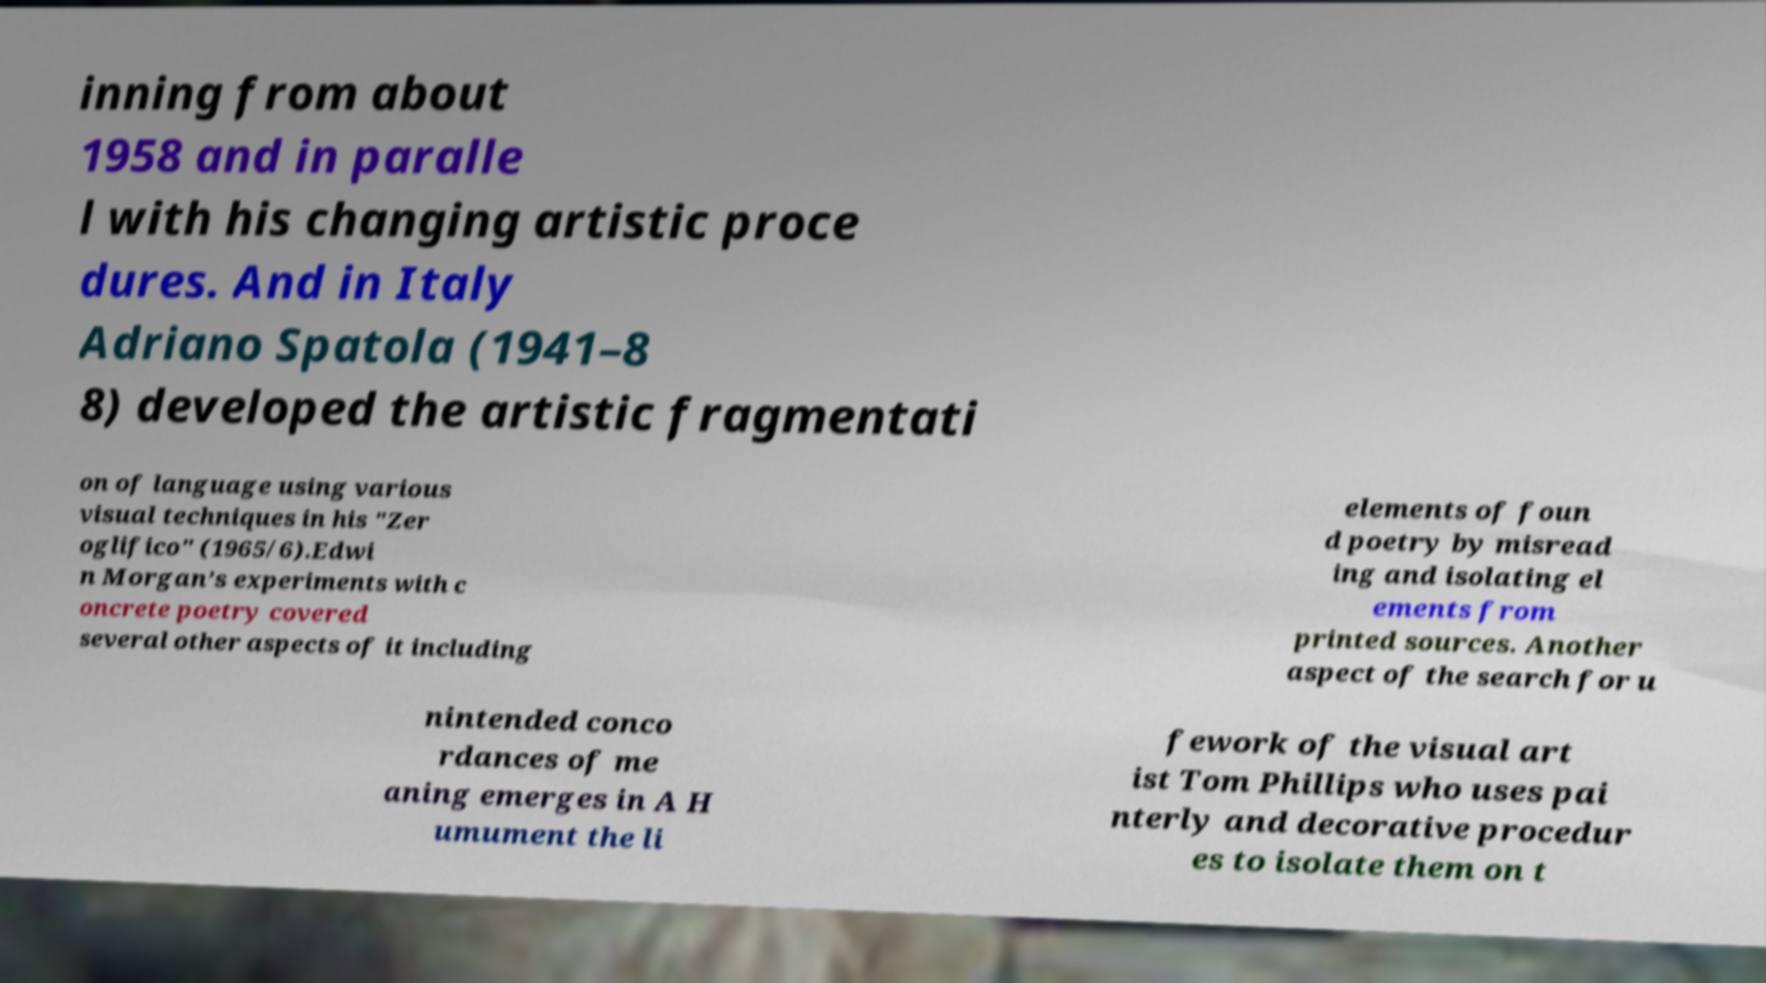Can you read and provide the text displayed in the image?This photo seems to have some interesting text. Can you extract and type it out for me? inning from about 1958 and in paralle l with his changing artistic proce dures. And in Italy Adriano Spatola (1941–8 8) developed the artistic fragmentati on of language using various visual techniques in his "Zer oglifico" (1965/6).Edwi n Morgan’s experiments with c oncrete poetry covered several other aspects of it including elements of foun d poetry by misread ing and isolating el ements from printed sources. Another aspect of the search for u nintended conco rdances of me aning emerges in A H umument the li fework of the visual art ist Tom Phillips who uses pai nterly and decorative procedur es to isolate them on t 